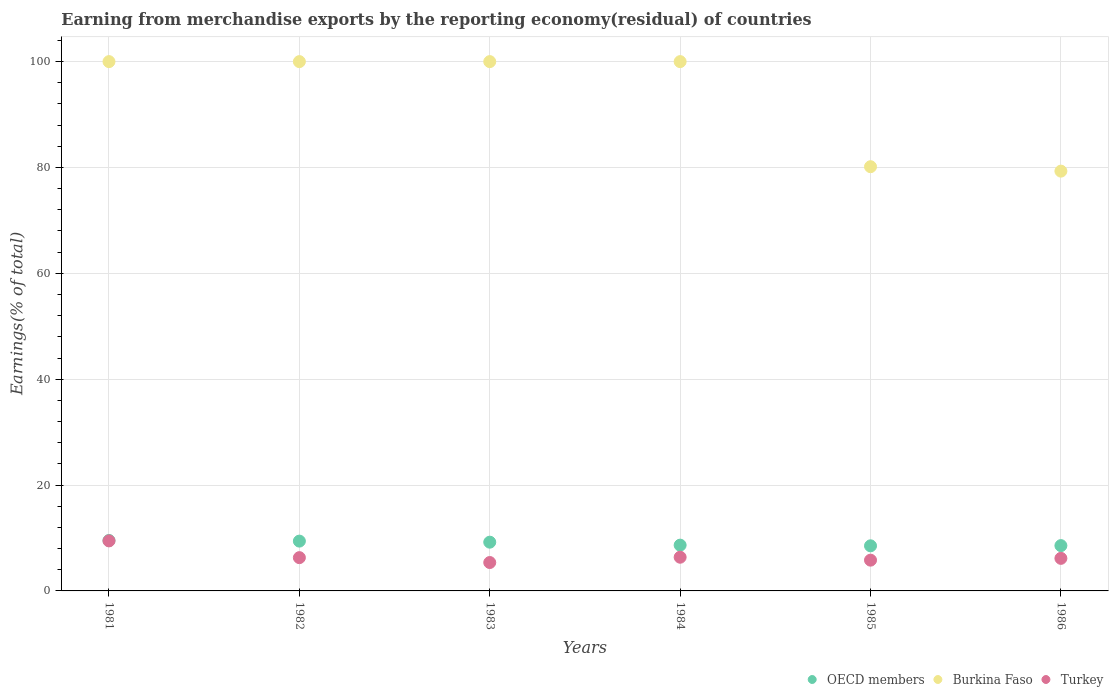Is the number of dotlines equal to the number of legend labels?
Your answer should be compact. Yes. What is the percentage of amount earned from merchandise exports in OECD members in 1986?
Offer a very short reply. 8.56. Across all years, what is the maximum percentage of amount earned from merchandise exports in Turkey?
Your response must be concise. 9.45. Across all years, what is the minimum percentage of amount earned from merchandise exports in Turkey?
Ensure brevity in your answer.  5.37. In which year was the percentage of amount earned from merchandise exports in Burkina Faso minimum?
Offer a very short reply. 1986. What is the total percentage of amount earned from merchandise exports in OECD members in the graph?
Provide a succinct answer. 53.88. What is the difference between the percentage of amount earned from merchandise exports in OECD members in 1985 and that in 1986?
Your answer should be very brief. -0.04. What is the difference between the percentage of amount earned from merchandise exports in Turkey in 1986 and the percentage of amount earned from merchandise exports in OECD members in 1982?
Give a very brief answer. -3.26. What is the average percentage of amount earned from merchandise exports in Turkey per year?
Provide a short and direct response. 6.57. In the year 1981, what is the difference between the percentage of amount earned from merchandise exports in Turkey and percentage of amount earned from merchandise exports in OECD members?
Ensure brevity in your answer.  -0.08. Is the percentage of amount earned from merchandise exports in OECD members in 1982 less than that in 1985?
Ensure brevity in your answer.  No. Is the difference between the percentage of amount earned from merchandise exports in Turkey in 1982 and 1985 greater than the difference between the percentage of amount earned from merchandise exports in OECD members in 1982 and 1985?
Your answer should be compact. No. What is the difference between the highest and the second highest percentage of amount earned from merchandise exports in Turkey?
Your response must be concise. 3.09. What is the difference between the highest and the lowest percentage of amount earned from merchandise exports in Turkey?
Ensure brevity in your answer.  4.09. Is the sum of the percentage of amount earned from merchandise exports in OECD members in 1983 and 1984 greater than the maximum percentage of amount earned from merchandise exports in Turkey across all years?
Ensure brevity in your answer.  Yes. Is the percentage of amount earned from merchandise exports in OECD members strictly less than the percentage of amount earned from merchandise exports in Burkina Faso over the years?
Make the answer very short. Yes. How many dotlines are there?
Your answer should be very brief. 3. What is the difference between two consecutive major ticks on the Y-axis?
Your answer should be compact. 20. Are the values on the major ticks of Y-axis written in scientific E-notation?
Your response must be concise. No. What is the title of the graph?
Give a very brief answer. Earning from merchandise exports by the reporting economy(residual) of countries. Does "Bhutan" appear as one of the legend labels in the graph?
Make the answer very short. No. What is the label or title of the Y-axis?
Provide a succinct answer. Earnings(% of total). What is the Earnings(% of total) of OECD members in 1981?
Your answer should be compact. 9.53. What is the Earnings(% of total) of Turkey in 1981?
Ensure brevity in your answer.  9.45. What is the Earnings(% of total) of OECD members in 1982?
Your answer should be compact. 9.41. What is the Earnings(% of total) in Turkey in 1982?
Your response must be concise. 6.29. What is the Earnings(% of total) in OECD members in 1983?
Make the answer very short. 9.21. What is the Earnings(% of total) of Burkina Faso in 1983?
Ensure brevity in your answer.  100. What is the Earnings(% of total) of Turkey in 1983?
Ensure brevity in your answer.  5.37. What is the Earnings(% of total) in OECD members in 1984?
Give a very brief answer. 8.65. What is the Earnings(% of total) in Turkey in 1984?
Your response must be concise. 6.37. What is the Earnings(% of total) in OECD members in 1985?
Offer a terse response. 8.52. What is the Earnings(% of total) in Burkina Faso in 1985?
Provide a short and direct response. 80.15. What is the Earnings(% of total) in Turkey in 1985?
Keep it short and to the point. 5.81. What is the Earnings(% of total) of OECD members in 1986?
Give a very brief answer. 8.56. What is the Earnings(% of total) in Burkina Faso in 1986?
Offer a very short reply. 79.31. What is the Earnings(% of total) in Turkey in 1986?
Your response must be concise. 6.15. Across all years, what is the maximum Earnings(% of total) of OECD members?
Offer a terse response. 9.53. Across all years, what is the maximum Earnings(% of total) of Burkina Faso?
Offer a terse response. 100. Across all years, what is the maximum Earnings(% of total) of Turkey?
Your answer should be compact. 9.45. Across all years, what is the minimum Earnings(% of total) in OECD members?
Ensure brevity in your answer.  8.52. Across all years, what is the minimum Earnings(% of total) in Burkina Faso?
Your answer should be compact. 79.31. Across all years, what is the minimum Earnings(% of total) in Turkey?
Offer a very short reply. 5.37. What is the total Earnings(% of total) in OECD members in the graph?
Give a very brief answer. 53.88. What is the total Earnings(% of total) in Burkina Faso in the graph?
Make the answer very short. 559.46. What is the total Earnings(% of total) of Turkey in the graph?
Your response must be concise. 39.44. What is the difference between the Earnings(% of total) of OECD members in 1981 and that in 1982?
Give a very brief answer. 0.12. What is the difference between the Earnings(% of total) of Turkey in 1981 and that in 1982?
Give a very brief answer. 3.17. What is the difference between the Earnings(% of total) in OECD members in 1981 and that in 1983?
Offer a very short reply. 0.32. What is the difference between the Earnings(% of total) of Turkey in 1981 and that in 1983?
Offer a very short reply. 4.09. What is the difference between the Earnings(% of total) in OECD members in 1981 and that in 1984?
Keep it short and to the point. 0.88. What is the difference between the Earnings(% of total) in Burkina Faso in 1981 and that in 1984?
Give a very brief answer. 0. What is the difference between the Earnings(% of total) of Turkey in 1981 and that in 1984?
Offer a terse response. 3.09. What is the difference between the Earnings(% of total) in OECD members in 1981 and that in 1985?
Provide a short and direct response. 1.01. What is the difference between the Earnings(% of total) of Burkina Faso in 1981 and that in 1985?
Provide a succinct answer. 19.85. What is the difference between the Earnings(% of total) of Turkey in 1981 and that in 1985?
Provide a succinct answer. 3.64. What is the difference between the Earnings(% of total) of OECD members in 1981 and that in 1986?
Provide a short and direct response. 0.97. What is the difference between the Earnings(% of total) of Burkina Faso in 1981 and that in 1986?
Keep it short and to the point. 20.69. What is the difference between the Earnings(% of total) in Turkey in 1981 and that in 1986?
Your response must be concise. 3.3. What is the difference between the Earnings(% of total) in OECD members in 1982 and that in 1983?
Provide a succinct answer. 0.2. What is the difference between the Earnings(% of total) of Turkey in 1982 and that in 1983?
Your answer should be compact. 0.92. What is the difference between the Earnings(% of total) in OECD members in 1982 and that in 1984?
Offer a very short reply. 0.76. What is the difference between the Earnings(% of total) in Turkey in 1982 and that in 1984?
Your response must be concise. -0.08. What is the difference between the Earnings(% of total) in OECD members in 1982 and that in 1985?
Provide a succinct answer. 0.89. What is the difference between the Earnings(% of total) in Burkina Faso in 1982 and that in 1985?
Give a very brief answer. 19.85. What is the difference between the Earnings(% of total) of Turkey in 1982 and that in 1985?
Offer a terse response. 0.47. What is the difference between the Earnings(% of total) in OECD members in 1982 and that in 1986?
Provide a succinct answer. 0.85. What is the difference between the Earnings(% of total) of Burkina Faso in 1982 and that in 1986?
Your answer should be very brief. 20.69. What is the difference between the Earnings(% of total) of Turkey in 1982 and that in 1986?
Keep it short and to the point. 0.13. What is the difference between the Earnings(% of total) in OECD members in 1983 and that in 1984?
Your answer should be compact. 0.56. What is the difference between the Earnings(% of total) in Turkey in 1983 and that in 1984?
Your answer should be compact. -1. What is the difference between the Earnings(% of total) of OECD members in 1983 and that in 1985?
Provide a short and direct response. 0.69. What is the difference between the Earnings(% of total) in Burkina Faso in 1983 and that in 1985?
Your response must be concise. 19.85. What is the difference between the Earnings(% of total) in Turkey in 1983 and that in 1985?
Your answer should be compact. -0.45. What is the difference between the Earnings(% of total) of OECD members in 1983 and that in 1986?
Your answer should be very brief. 0.65. What is the difference between the Earnings(% of total) of Burkina Faso in 1983 and that in 1986?
Ensure brevity in your answer.  20.69. What is the difference between the Earnings(% of total) of Turkey in 1983 and that in 1986?
Keep it short and to the point. -0.79. What is the difference between the Earnings(% of total) in OECD members in 1984 and that in 1985?
Give a very brief answer. 0.13. What is the difference between the Earnings(% of total) in Burkina Faso in 1984 and that in 1985?
Make the answer very short. 19.85. What is the difference between the Earnings(% of total) in Turkey in 1984 and that in 1985?
Make the answer very short. 0.55. What is the difference between the Earnings(% of total) of OECD members in 1984 and that in 1986?
Give a very brief answer. 0.09. What is the difference between the Earnings(% of total) in Burkina Faso in 1984 and that in 1986?
Offer a terse response. 20.69. What is the difference between the Earnings(% of total) in Turkey in 1984 and that in 1986?
Offer a terse response. 0.21. What is the difference between the Earnings(% of total) of OECD members in 1985 and that in 1986?
Your answer should be very brief. -0.04. What is the difference between the Earnings(% of total) of Burkina Faso in 1985 and that in 1986?
Give a very brief answer. 0.84. What is the difference between the Earnings(% of total) of Turkey in 1985 and that in 1986?
Offer a very short reply. -0.34. What is the difference between the Earnings(% of total) of OECD members in 1981 and the Earnings(% of total) of Burkina Faso in 1982?
Ensure brevity in your answer.  -90.47. What is the difference between the Earnings(% of total) of OECD members in 1981 and the Earnings(% of total) of Turkey in 1982?
Make the answer very short. 3.24. What is the difference between the Earnings(% of total) in Burkina Faso in 1981 and the Earnings(% of total) in Turkey in 1982?
Your answer should be very brief. 93.71. What is the difference between the Earnings(% of total) in OECD members in 1981 and the Earnings(% of total) in Burkina Faso in 1983?
Your response must be concise. -90.47. What is the difference between the Earnings(% of total) in OECD members in 1981 and the Earnings(% of total) in Turkey in 1983?
Offer a very short reply. 4.17. What is the difference between the Earnings(% of total) in Burkina Faso in 1981 and the Earnings(% of total) in Turkey in 1983?
Provide a succinct answer. 94.63. What is the difference between the Earnings(% of total) of OECD members in 1981 and the Earnings(% of total) of Burkina Faso in 1984?
Provide a succinct answer. -90.47. What is the difference between the Earnings(% of total) of OECD members in 1981 and the Earnings(% of total) of Turkey in 1984?
Provide a short and direct response. 3.17. What is the difference between the Earnings(% of total) in Burkina Faso in 1981 and the Earnings(% of total) in Turkey in 1984?
Ensure brevity in your answer.  93.63. What is the difference between the Earnings(% of total) of OECD members in 1981 and the Earnings(% of total) of Burkina Faso in 1985?
Make the answer very short. -70.61. What is the difference between the Earnings(% of total) of OECD members in 1981 and the Earnings(% of total) of Turkey in 1985?
Provide a succinct answer. 3.72. What is the difference between the Earnings(% of total) of Burkina Faso in 1981 and the Earnings(% of total) of Turkey in 1985?
Offer a very short reply. 94.19. What is the difference between the Earnings(% of total) of OECD members in 1981 and the Earnings(% of total) of Burkina Faso in 1986?
Provide a short and direct response. -69.78. What is the difference between the Earnings(% of total) of OECD members in 1981 and the Earnings(% of total) of Turkey in 1986?
Keep it short and to the point. 3.38. What is the difference between the Earnings(% of total) of Burkina Faso in 1981 and the Earnings(% of total) of Turkey in 1986?
Offer a very short reply. 93.85. What is the difference between the Earnings(% of total) of OECD members in 1982 and the Earnings(% of total) of Burkina Faso in 1983?
Your answer should be very brief. -90.59. What is the difference between the Earnings(% of total) in OECD members in 1982 and the Earnings(% of total) in Turkey in 1983?
Offer a terse response. 4.04. What is the difference between the Earnings(% of total) of Burkina Faso in 1982 and the Earnings(% of total) of Turkey in 1983?
Your answer should be very brief. 94.63. What is the difference between the Earnings(% of total) in OECD members in 1982 and the Earnings(% of total) in Burkina Faso in 1984?
Make the answer very short. -90.59. What is the difference between the Earnings(% of total) of OECD members in 1982 and the Earnings(% of total) of Turkey in 1984?
Make the answer very short. 3.05. What is the difference between the Earnings(% of total) of Burkina Faso in 1982 and the Earnings(% of total) of Turkey in 1984?
Offer a very short reply. 93.63. What is the difference between the Earnings(% of total) of OECD members in 1982 and the Earnings(% of total) of Burkina Faso in 1985?
Provide a succinct answer. -70.74. What is the difference between the Earnings(% of total) in OECD members in 1982 and the Earnings(% of total) in Turkey in 1985?
Offer a very short reply. 3.6. What is the difference between the Earnings(% of total) in Burkina Faso in 1982 and the Earnings(% of total) in Turkey in 1985?
Provide a succinct answer. 94.19. What is the difference between the Earnings(% of total) in OECD members in 1982 and the Earnings(% of total) in Burkina Faso in 1986?
Give a very brief answer. -69.9. What is the difference between the Earnings(% of total) of OECD members in 1982 and the Earnings(% of total) of Turkey in 1986?
Make the answer very short. 3.26. What is the difference between the Earnings(% of total) in Burkina Faso in 1982 and the Earnings(% of total) in Turkey in 1986?
Provide a succinct answer. 93.85. What is the difference between the Earnings(% of total) in OECD members in 1983 and the Earnings(% of total) in Burkina Faso in 1984?
Make the answer very short. -90.79. What is the difference between the Earnings(% of total) of OECD members in 1983 and the Earnings(% of total) of Turkey in 1984?
Your response must be concise. 2.84. What is the difference between the Earnings(% of total) of Burkina Faso in 1983 and the Earnings(% of total) of Turkey in 1984?
Provide a succinct answer. 93.63. What is the difference between the Earnings(% of total) in OECD members in 1983 and the Earnings(% of total) in Burkina Faso in 1985?
Your answer should be compact. -70.94. What is the difference between the Earnings(% of total) of OECD members in 1983 and the Earnings(% of total) of Turkey in 1985?
Provide a succinct answer. 3.4. What is the difference between the Earnings(% of total) of Burkina Faso in 1983 and the Earnings(% of total) of Turkey in 1985?
Your response must be concise. 94.19. What is the difference between the Earnings(% of total) of OECD members in 1983 and the Earnings(% of total) of Burkina Faso in 1986?
Your answer should be very brief. -70.1. What is the difference between the Earnings(% of total) of OECD members in 1983 and the Earnings(% of total) of Turkey in 1986?
Your response must be concise. 3.06. What is the difference between the Earnings(% of total) of Burkina Faso in 1983 and the Earnings(% of total) of Turkey in 1986?
Keep it short and to the point. 93.85. What is the difference between the Earnings(% of total) in OECD members in 1984 and the Earnings(% of total) in Burkina Faso in 1985?
Provide a short and direct response. -71.5. What is the difference between the Earnings(% of total) of OECD members in 1984 and the Earnings(% of total) of Turkey in 1985?
Offer a very short reply. 2.84. What is the difference between the Earnings(% of total) of Burkina Faso in 1984 and the Earnings(% of total) of Turkey in 1985?
Your response must be concise. 94.19. What is the difference between the Earnings(% of total) in OECD members in 1984 and the Earnings(% of total) in Burkina Faso in 1986?
Your response must be concise. -70.66. What is the difference between the Earnings(% of total) in OECD members in 1984 and the Earnings(% of total) in Turkey in 1986?
Make the answer very short. 2.49. What is the difference between the Earnings(% of total) of Burkina Faso in 1984 and the Earnings(% of total) of Turkey in 1986?
Provide a succinct answer. 93.85. What is the difference between the Earnings(% of total) of OECD members in 1985 and the Earnings(% of total) of Burkina Faso in 1986?
Provide a short and direct response. -70.79. What is the difference between the Earnings(% of total) of OECD members in 1985 and the Earnings(% of total) of Turkey in 1986?
Keep it short and to the point. 2.37. What is the difference between the Earnings(% of total) of Burkina Faso in 1985 and the Earnings(% of total) of Turkey in 1986?
Give a very brief answer. 73.99. What is the average Earnings(% of total) of OECD members per year?
Make the answer very short. 8.98. What is the average Earnings(% of total) in Burkina Faso per year?
Your answer should be very brief. 93.24. What is the average Earnings(% of total) of Turkey per year?
Offer a terse response. 6.57. In the year 1981, what is the difference between the Earnings(% of total) of OECD members and Earnings(% of total) of Burkina Faso?
Offer a terse response. -90.47. In the year 1981, what is the difference between the Earnings(% of total) of OECD members and Earnings(% of total) of Turkey?
Your response must be concise. 0.08. In the year 1981, what is the difference between the Earnings(% of total) of Burkina Faso and Earnings(% of total) of Turkey?
Your response must be concise. 90.55. In the year 1982, what is the difference between the Earnings(% of total) of OECD members and Earnings(% of total) of Burkina Faso?
Keep it short and to the point. -90.59. In the year 1982, what is the difference between the Earnings(% of total) of OECD members and Earnings(% of total) of Turkey?
Your answer should be very brief. 3.12. In the year 1982, what is the difference between the Earnings(% of total) of Burkina Faso and Earnings(% of total) of Turkey?
Your response must be concise. 93.71. In the year 1983, what is the difference between the Earnings(% of total) of OECD members and Earnings(% of total) of Burkina Faso?
Your answer should be very brief. -90.79. In the year 1983, what is the difference between the Earnings(% of total) of OECD members and Earnings(% of total) of Turkey?
Give a very brief answer. 3.84. In the year 1983, what is the difference between the Earnings(% of total) in Burkina Faso and Earnings(% of total) in Turkey?
Provide a succinct answer. 94.63. In the year 1984, what is the difference between the Earnings(% of total) in OECD members and Earnings(% of total) in Burkina Faso?
Ensure brevity in your answer.  -91.35. In the year 1984, what is the difference between the Earnings(% of total) in OECD members and Earnings(% of total) in Turkey?
Your answer should be compact. 2.28. In the year 1984, what is the difference between the Earnings(% of total) of Burkina Faso and Earnings(% of total) of Turkey?
Provide a succinct answer. 93.63. In the year 1985, what is the difference between the Earnings(% of total) in OECD members and Earnings(% of total) in Burkina Faso?
Ensure brevity in your answer.  -71.63. In the year 1985, what is the difference between the Earnings(% of total) of OECD members and Earnings(% of total) of Turkey?
Ensure brevity in your answer.  2.71. In the year 1985, what is the difference between the Earnings(% of total) of Burkina Faso and Earnings(% of total) of Turkey?
Ensure brevity in your answer.  74.33. In the year 1986, what is the difference between the Earnings(% of total) of OECD members and Earnings(% of total) of Burkina Faso?
Give a very brief answer. -70.75. In the year 1986, what is the difference between the Earnings(% of total) of OECD members and Earnings(% of total) of Turkey?
Give a very brief answer. 2.41. In the year 1986, what is the difference between the Earnings(% of total) in Burkina Faso and Earnings(% of total) in Turkey?
Provide a succinct answer. 73.16. What is the ratio of the Earnings(% of total) in OECD members in 1981 to that in 1982?
Provide a short and direct response. 1.01. What is the ratio of the Earnings(% of total) in Turkey in 1981 to that in 1982?
Your answer should be very brief. 1.5. What is the ratio of the Earnings(% of total) in OECD members in 1981 to that in 1983?
Your answer should be compact. 1.03. What is the ratio of the Earnings(% of total) of Burkina Faso in 1981 to that in 1983?
Make the answer very short. 1. What is the ratio of the Earnings(% of total) of Turkey in 1981 to that in 1983?
Provide a succinct answer. 1.76. What is the ratio of the Earnings(% of total) of OECD members in 1981 to that in 1984?
Your answer should be very brief. 1.1. What is the ratio of the Earnings(% of total) of Burkina Faso in 1981 to that in 1984?
Keep it short and to the point. 1. What is the ratio of the Earnings(% of total) in Turkey in 1981 to that in 1984?
Keep it short and to the point. 1.49. What is the ratio of the Earnings(% of total) of OECD members in 1981 to that in 1985?
Provide a succinct answer. 1.12. What is the ratio of the Earnings(% of total) of Burkina Faso in 1981 to that in 1985?
Your answer should be compact. 1.25. What is the ratio of the Earnings(% of total) of Turkey in 1981 to that in 1985?
Make the answer very short. 1.63. What is the ratio of the Earnings(% of total) of OECD members in 1981 to that in 1986?
Keep it short and to the point. 1.11. What is the ratio of the Earnings(% of total) of Burkina Faso in 1981 to that in 1986?
Your answer should be compact. 1.26. What is the ratio of the Earnings(% of total) in Turkey in 1981 to that in 1986?
Offer a terse response. 1.54. What is the ratio of the Earnings(% of total) of OECD members in 1982 to that in 1983?
Your answer should be very brief. 1.02. What is the ratio of the Earnings(% of total) in Turkey in 1982 to that in 1983?
Your answer should be compact. 1.17. What is the ratio of the Earnings(% of total) of OECD members in 1982 to that in 1984?
Provide a succinct answer. 1.09. What is the ratio of the Earnings(% of total) in Turkey in 1982 to that in 1984?
Give a very brief answer. 0.99. What is the ratio of the Earnings(% of total) of OECD members in 1982 to that in 1985?
Provide a short and direct response. 1.1. What is the ratio of the Earnings(% of total) in Burkina Faso in 1982 to that in 1985?
Offer a terse response. 1.25. What is the ratio of the Earnings(% of total) in Turkey in 1982 to that in 1985?
Provide a short and direct response. 1.08. What is the ratio of the Earnings(% of total) in OECD members in 1982 to that in 1986?
Your answer should be very brief. 1.1. What is the ratio of the Earnings(% of total) in Burkina Faso in 1982 to that in 1986?
Offer a very short reply. 1.26. What is the ratio of the Earnings(% of total) of Turkey in 1982 to that in 1986?
Offer a terse response. 1.02. What is the ratio of the Earnings(% of total) of OECD members in 1983 to that in 1984?
Offer a very short reply. 1.06. What is the ratio of the Earnings(% of total) of Turkey in 1983 to that in 1984?
Your response must be concise. 0.84. What is the ratio of the Earnings(% of total) in OECD members in 1983 to that in 1985?
Ensure brevity in your answer.  1.08. What is the ratio of the Earnings(% of total) in Burkina Faso in 1983 to that in 1985?
Provide a short and direct response. 1.25. What is the ratio of the Earnings(% of total) of Turkey in 1983 to that in 1985?
Your answer should be compact. 0.92. What is the ratio of the Earnings(% of total) of OECD members in 1983 to that in 1986?
Keep it short and to the point. 1.08. What is the ratio of the Earnings(% of total) of Burkina Faso in 1983 to that in 1986?
Offer a terse response. 1.26. What is the ratio of the Earnings(% of total) in Turkey in 1983 to that in 1986?
Ensure brevity in your answer.  0.87. What is the ratio of the Earnings(% of total) of OECD members in 1984 to that in 1985?
Provide a short and direct response. 1.01. What is the ratio of the Earnings(% of total) in Burkina Faso in 1984 to that in 1985?
Your answer should be very brief. 1.25. What is the ratio of the Earnings(% of total) in Turkey in 1984 to that in 1985?
Your response must be concise. 1.1. What is the ratio of the Earnings(% of total) in OECD members in 1984 to that in 1986?
Your response must be concise. 1.01. What is the ratio of the Earnings(% of total) in Burkina Faso in 1984 to that in 1986?
Keep it short and to the point. 1.26. What is the ratio of the Earnings(% of total) of Turkey in 1984 to that in 1986?
Make the answer very short. 1.03. What is the ratio of the Earnings(% of total) in OECD members in 1985 to that in 1986?
Keep it short and to the point. 1. What is the ratio of the Earnings(% of total) of Burkina Faso in 1985 to that in 1986?
Keep it short and to the point. 1.01. What is the ratio of the Earnings(% of total) in Turkey in 1985 to that in 1986?
Keep it short and to the point. 0.94. What is the difference between the highest and the second highest Earnings(% of total) in OECD members?
Provide a short and direct response. 0.12. What is the difference between the highest and the second highest Earnings(% of total) in Turkey?
Give a very brief answer. 3.09. What is the difference between the highest and the lowest Earnings(% of total) in OECD members?
Offer a terse response. 1.01. What is the difference between the highest and the lowest Earnings(% of total) in Burkina Faso?
Give a very brief answer. 20.69. What is the difference between the highest and the lowest Earnings(% of total) of Turkey?
Your answer should be very brief. 4.09. 